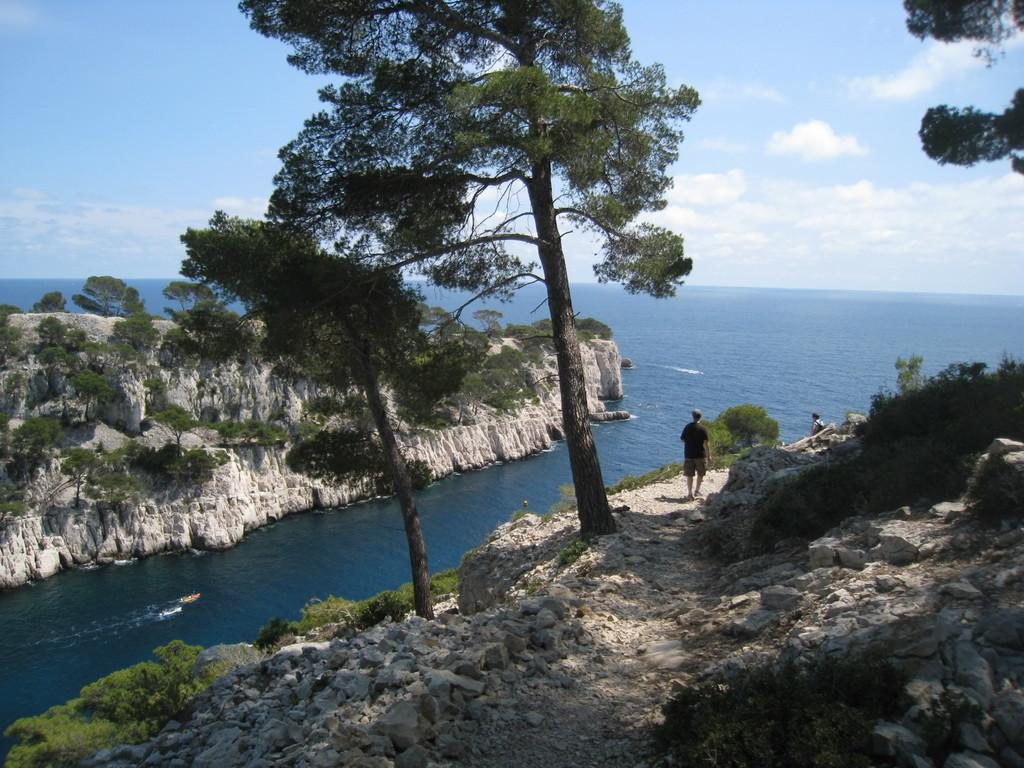What type of scene is depicted in the image? The image depicts a nature scene. What geological features can be seen in the scene? There are rocks in the scene. What type of vegetation is present in the scene? There are trees in the scene. What body of water is visible in the scene? There is blue sea water visible in the scene. What is the condition of the sky in the scene? The sky is clear and blue in the scene. How many points are visible on the sand in the image? There is no sand visible in the image, and therefore no points can be counted. 